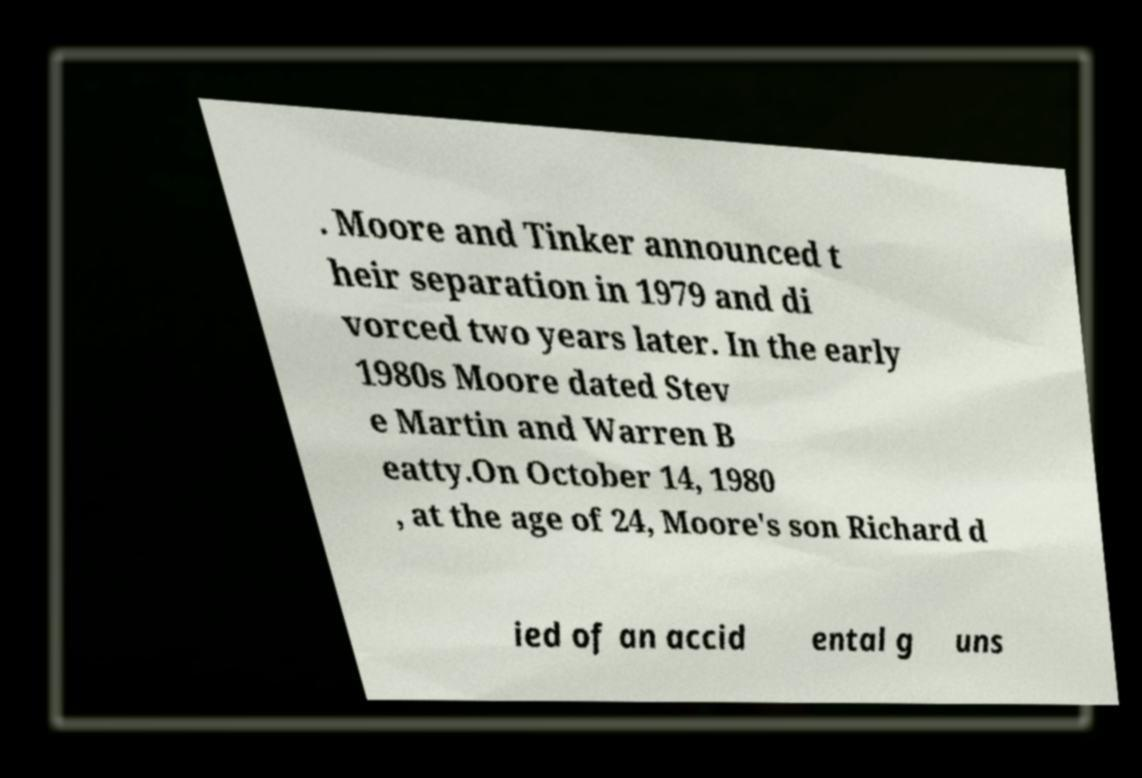I need the written content from this picture converted into text. Can you do that? . Moore and Tinker announced t heir separation in 1979 and di vorced two years later. In the early 1980s Moore dated Stev e Martin and Warren B eatty.On October 14, 1980 , at the age of 24, Moore's son Richard d ied of an accid ental g uns 